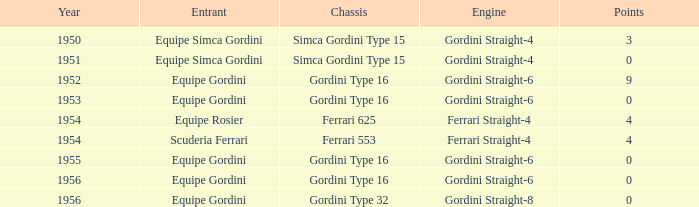What framework has under 9 points by equipe rosier? Ferrari 625. 